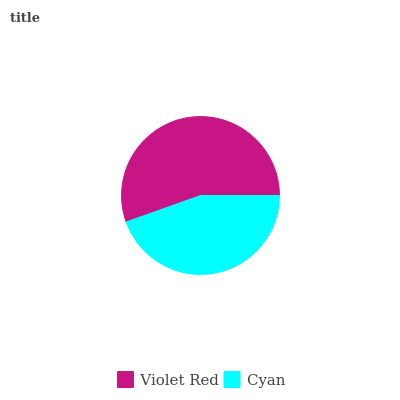Is Cyan the minimum?
Answer yes or no. Yes. Is Violet Red the maximum?
Answer yes or no. Yes. Is Cyan the maximum?
Answer yes or no. No. Is Violet Red greater than Cyan?
Answer yes or no. Yes. Is Cyan less than Violet Red?
Answer yes or no. Yes. Is Cyan greater than Violet Red?
Answer yes or no. No. Is Violet Red less than Cyan?
Answer yes or no. No. Is Violet Red the high median?
Answer yes or no. Yes. Is Cyan the low median?
Answer yes or no. Yes. Is Cyan the high median?
Answer yes or no. No. Is Violet Red the low median?
Answer yes or no. No. 